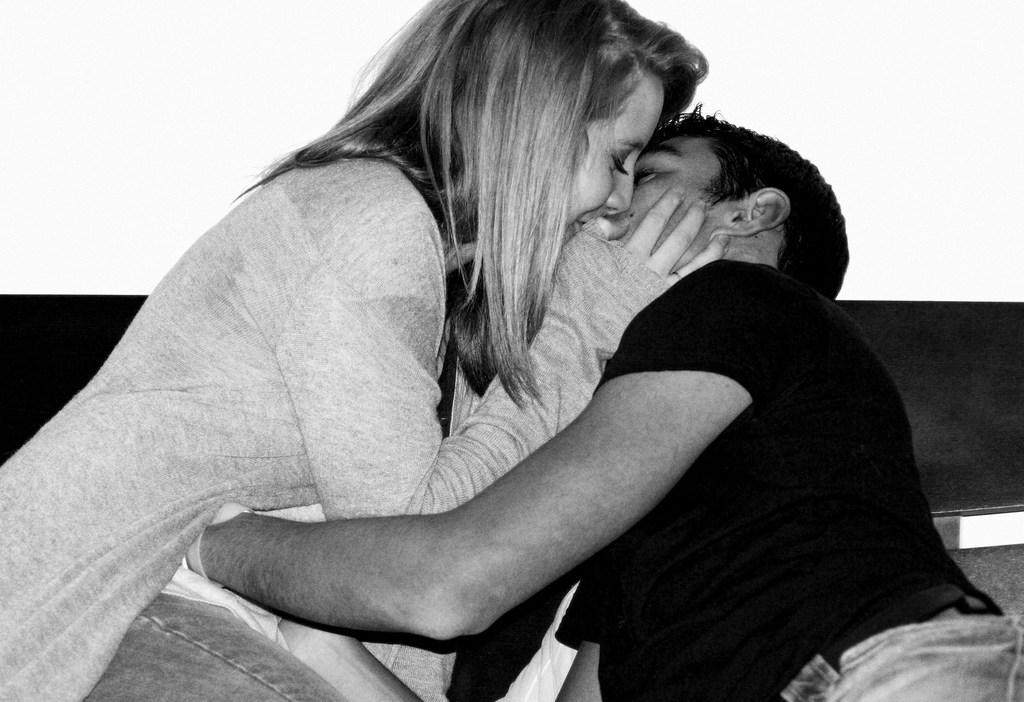How many people are in the image? There are two people in the image. What are the people wearing? The people are wearing dresses. What is the color scheme of the image? The image is black and white. Can you hear the whistle in the image? There is no whistle present in the image, so it cannot be heard. 